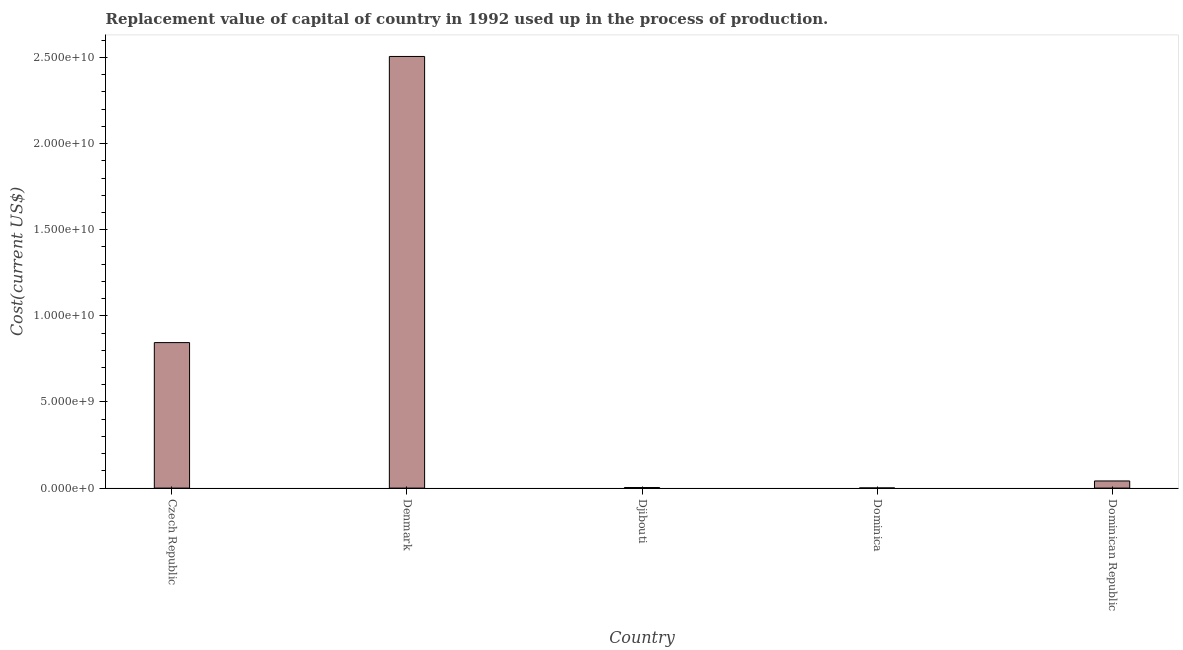Does the graph contain any zero values?
Make the answer very short. No. Does the graph contain grids?
Your response must be concise. No. What is the title of the graph?
Your response must be concise. Replacement value of capital of country in 1992 used up in the process of production. What is the label or title of the X-axis?
Offer a very short reply. Country. What is the label or title of the Y-axis?
Ensure brevity in your answer.  Cost(current US$). What is the consumption of fixed capital in Dominica?
Give a very brief answer. 8.29e+06. Across all countries, what is the maximum consumption of fixed capital?
Provide a succinct answer. 2.51e+1. Across all countries, what is the minimum consumption of fixed capital?
Provide a succinct answer. 8.29e+06. In which country was the consumption of fixed capital maximum?
Ensure brevity in your answer.  Denmark. In which country was the consumption of fixed capital minimum?
Provide a short and direct response. Dominica. What is the sum of the consumption of fixed capital?
Your answer should be compact. 3.40e+1. What is the difference between the consumption of fixed capital in Czech Republic and Denmark?
Make the answer very short. -1.66e+1. What is the average consumption of fixed capital per country?
Make the answer very short. 6.79e+09. What is the median consumption of fixed capital?
Your response must be concise. 4.14e+08. What is the ratio of the consumption of fixed capital in Denmark to that in Dominican Republic?
Keep it short and to the point. 60.54. What is the difference between the highest and the second highest consumption of fixed capital?
Offer a terse response. 1.66e+1. Is the sum of the consumption of fixed capital in Denmark and Djibouti greater than the maximum consumption of fixed capital across all countries?
Provide a succinct answer. Yes. What is the difference between the highest and the lowest consumption of fixed capital?
Your answer should be compact. 2.51e+1. How many countries are there in the graph?
Your answer should be compact. 5. Are the values on the major ticks of Y-axis written in scientific E-notation?
Your answer should be very brief. Yes. What is the Cost(current US$) in Czech Republic?
Offer a very short reply. 8.45e+09. What is the Cost(current US$) in Denmark?
Your answer should be very brief. 2.51e+1. What is the Cost(current US$) in Djibouti?
Offer a terse response. 3.20e+07. What is the Cost(current US$) in Dominica?
Offer a terse response. 8.29e+06. What is the Cost(current US$) in Dominican Republic?
Provide a short and direct response. 4.14e+08. What is the difference between the Cost(current US$) in Czech Republic and Denmark?
Ensure brevity in your answer.  -1.66e+1. What is the difference between the Cost(current US$) in Czech Republic and Djibouti?
Provide a succinct answer. 8.42e+09. What is the difference between the Cost(current US$) in Czech Republic and Dominica?
Give a very brief answer. 8.44e+09. What is the difference between the Cost(current US$) in Czech Republic and Dominican Republic?
Your response must be concise. 8.03e+09. What is the difference between the Cost(current US$) in Denmark and Djibouti?
Your response must be concise. 2.50e+1. What is the difference between the Cost(current US$) in Denmark and Dominica?
Your answer should be very brief. 2.51e+1. What is the difference between the Cost(current US$) in Denmark and Dominican Republic?
Your answer should be compact. 2.46e+1. What is the difference between the Cost(current US$) in Djibouti and Dominica?
Offer a very short reply. 2.37e+07. What is the difference between the Cost(current US$) in Djibouti and Dominican Republic?
Ensure brevity in your answer.  -3.82e+08. What is the difference between the Cost(current US$) in Dominica and Dominican Republic?
Ensure brevity in your answer.  -4.06e+08. What is the ratio of the Cost(current US$) in Czech Republic to that in Denmark?
Provide a short and direct response. 0.34. What is the ratio of the Cost(current US$) in Czech Republic to that in Djibouti?
Offer a very short reply. 263.83. What is the ratio of the Cost(current US$) in Czech Republic to that in Dominica?
Give a very brief answer. 1019.5. What is the ratio of the Cost(current US$) in Czech Republic to that in Dominican Republic?
Your answer should be very brief. 20.41. What is the ratio of the Cost(current US$) in Denmark to that in Djibouti?
Offer a very short reply. 782.7. What is the ratio of the Cost(current US$) in Denmark to that in Dominica?
Your answer should be very brief. 3024.52. What is the ratio of the Cost(current US$) in Denmark to that in Dominican Republic?
Your answer should be compact. 60.54. What is the ratio of the Cost(current US$) in Djibouti to that in Dominica?
Offer a very short reply. 3.86. What is the ratio of the Cost(current US$) in Djibouti to that in Dominican Republic?
Your answer should be very brief. 0.08. 